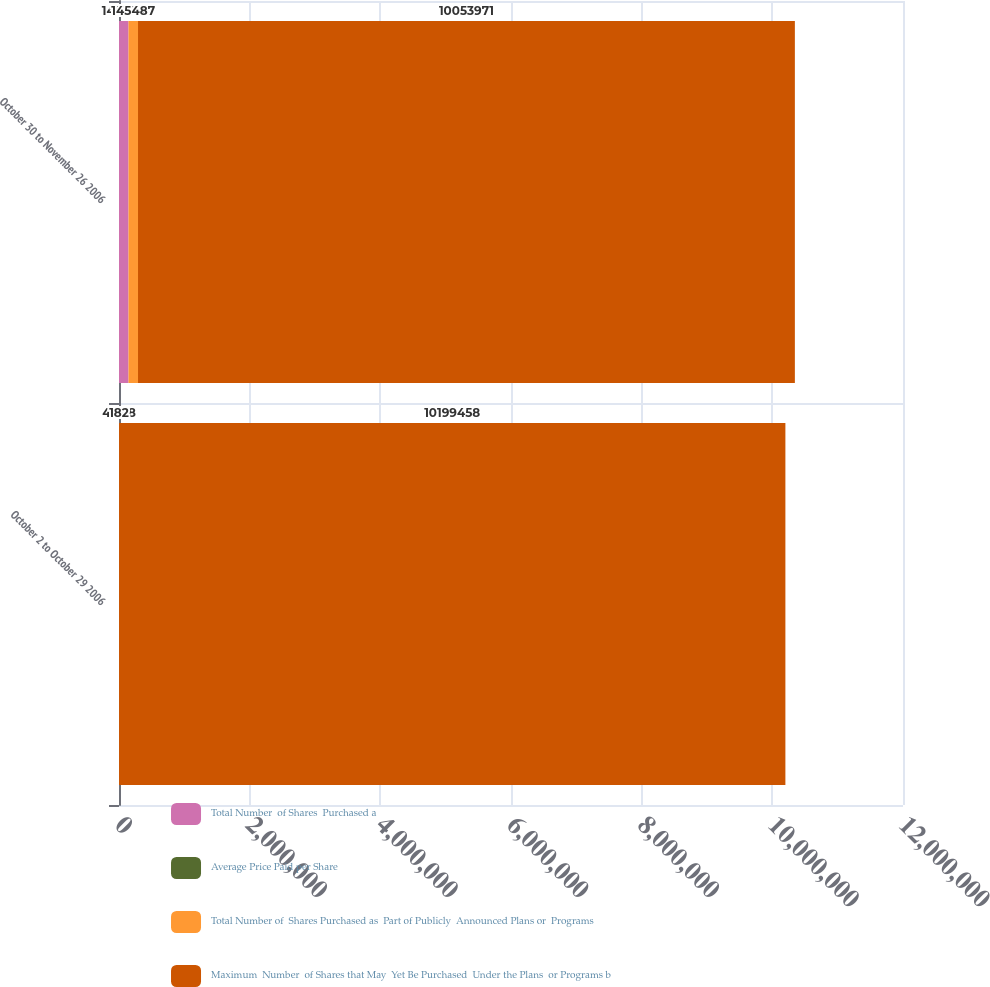<chart> <loc_0><loc_0><loc_500><loc_500><stacked_bar_chart><ecel><fcel>October 2 to October 29 2006<fcel>October 30 to November 26 2006<nl><fcel>Total Number  of Shares  Purchased a<fcel>182<fcel>145487<nl><fcel>Average Price Paid per Share<fcel>42.58<fcel>42.18<nl><fcel>Total Number of  Shares Purchased as  Part of Publicly  Announced Plans or  Programs<fcel>182<fcel>145487<nl><fcel>Maximum  Number  of Shares that May  Yet Be Purchased  Under the Plans  or Programs b<fcel>1.01995e+07<fcel>1.0054e+07<nl></chart> 